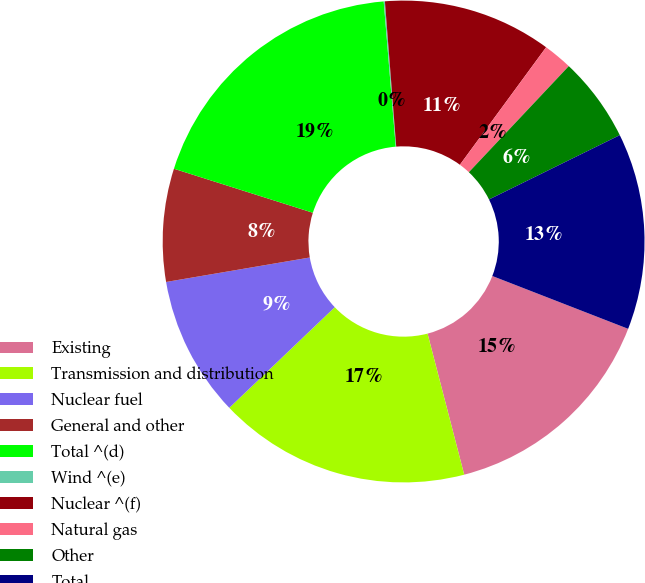Convert chart to OTSL. <chart><loc_0><loc_0><loc_500><loc_500><pie_chart><fcel>Existing<fcel>Transmission and distribution<fcel>Nuclear fuel<fcel>General and other<fcel>Total ^(d)<fcel>Wind ^(e)<fcel>Nuclear ^(f)<fcel>Natural gas<fcel>Other<fcel>Total<nl><fcel>15.05%<fcel>16.92%<fcel>9.44%<fcel>7.57%<fcel>18.8%<fcel>0.08%<fcel>11.31%<fcel>1.95%<fcel>5.7%<fcel>13.18%<nl></chart> 